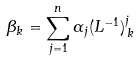Convert formula to latex. <formula><loc_0><loc_0><loc_500><loc_500>\beta _ { k } = \sum _ { j = 1 } ^ { n } \alpha _ { j } ( L ^ { - 1 } ) ^ { j } _ { \, k }</formula> 